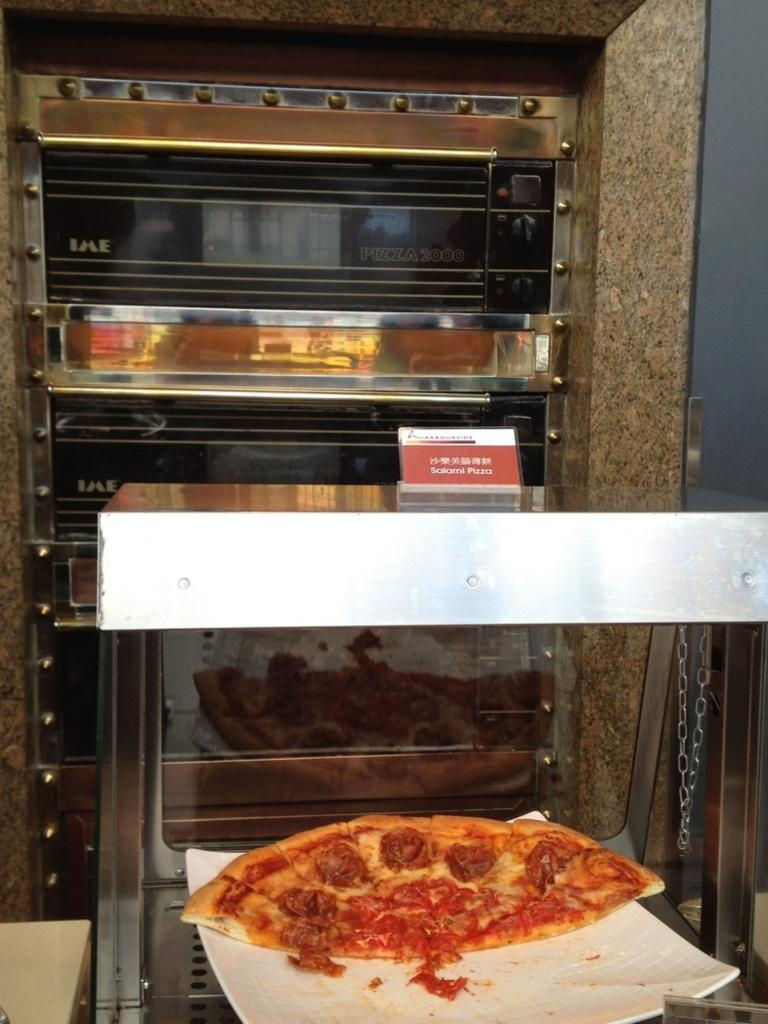What is the main subject in the foreground of the image? There is a pizza in the foreground of the image. How is the pizza presented in the image? The pizza is on a plate. What can be seen in the background of the image? There are ovens and a wall in the background of the image. Can you describe the setting where the image might have been taken? The image may have been taken in a hall, given the presence of ovens and a wall. What type of ink can be seen dripping from the pizza in the image? There is no ink present in the image, and the pizza is not depicted as dripping anything. 